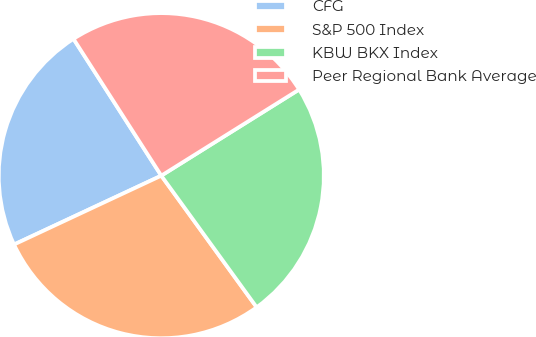Convert chart to OTSL. <chart><loc_0><loc_0><loc_500><loc_500><pie_chart><fcel>CFG<fcel>S&P 500 Index<fcel>KBW BKX Index<fcel>Peer Regional Bank Average<nl><fcel>22.88%<fcel>28.02%<fcel>23.91%<fcel>25.19%<nl></chart> 